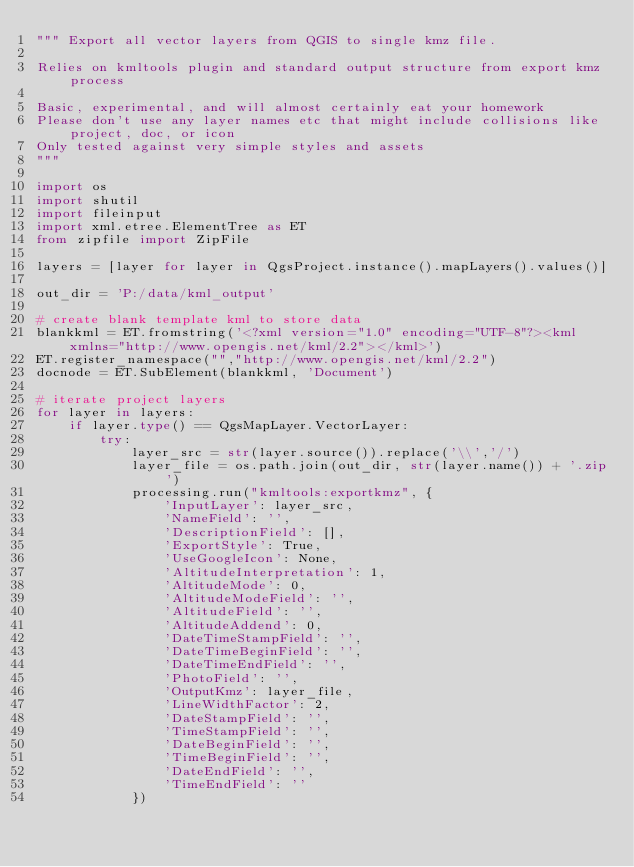Convert code to text. <code><loc_0><loc_0><loc_500><loc_500><_Python_>""" Export all vector layers from QGIS to single kmz file.

Relies on kmltools plugin and standard output structure from export kmz process

Basic, experimental, and will almost certainly eat your homework
Please don't use any layer names etc that might include collisions like project, doc, or icon
Only tested against very simple styles and assets
"""

import os
import shutil
import fileinput
import xml.etree.ElementTree as ET
from zipfile import ZipFile

layers = [layer for layer in QgsProject.instance().mapLayers().values()]

out_dir = 'P:/data/kml_output'

# create blank template kml to store data
blankkml = ET.fromstring('<?xml version="1.0" encoding="UTF-8"?><kml xmlns="http://www.opengis.net/kml/2.2"></kml>')
ET.register_namespace("","http://www.opengis.net/kml/2.2")
docnode = ET.SubElement(blankkml, 'Document')

# iterate project layers
for layer in layers:
    if layer.type() == QgsMapLayer.VectorLayer:
        try:
            layer_src = str(layer.source()).replace('\\','/')
            layer_file = os.path.join(out_dir, str(layer.name()) + '.zip')
            processing.run("kmltools:exportkmz", {
                'InputLayer': layer_src,
                'NameField': '',
                'DescriptionField': [],
                'ExportStyle': True,
                'UseGoogleIcon': None,
                'AltitudeInterpretation': 1,
                'AltitudeMode': 0,
                'AltitudeModeField': '',
                'AltitudeField': '',
                'AltitudeAddend': 0,
                'DateTimeStampField': '',
                'DateTimeBeginField': '',
                'DateTimeEndField': '',
                'PhotoField': '',
                'OutputKmz': layer_file,
                'LineWidthFactor': 2,
                'DateStampField': '',
                'TimeStampField': '',
                'DateBeginField': '',
                'TimeBeginField': '',
                'DateEndField': '',
                'TimeEndField': ''
            })</code> 